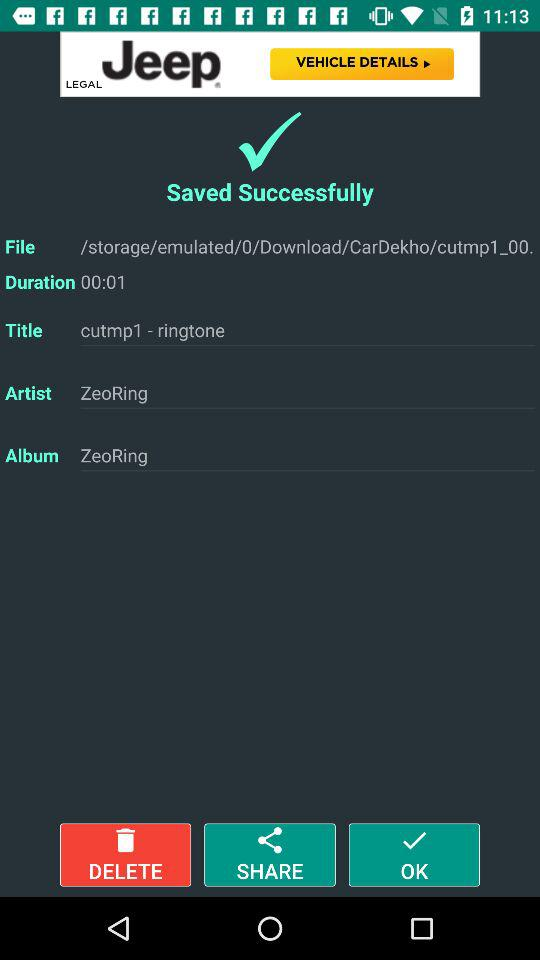What's the title of the album? The title of the album is "ZeoRing". 